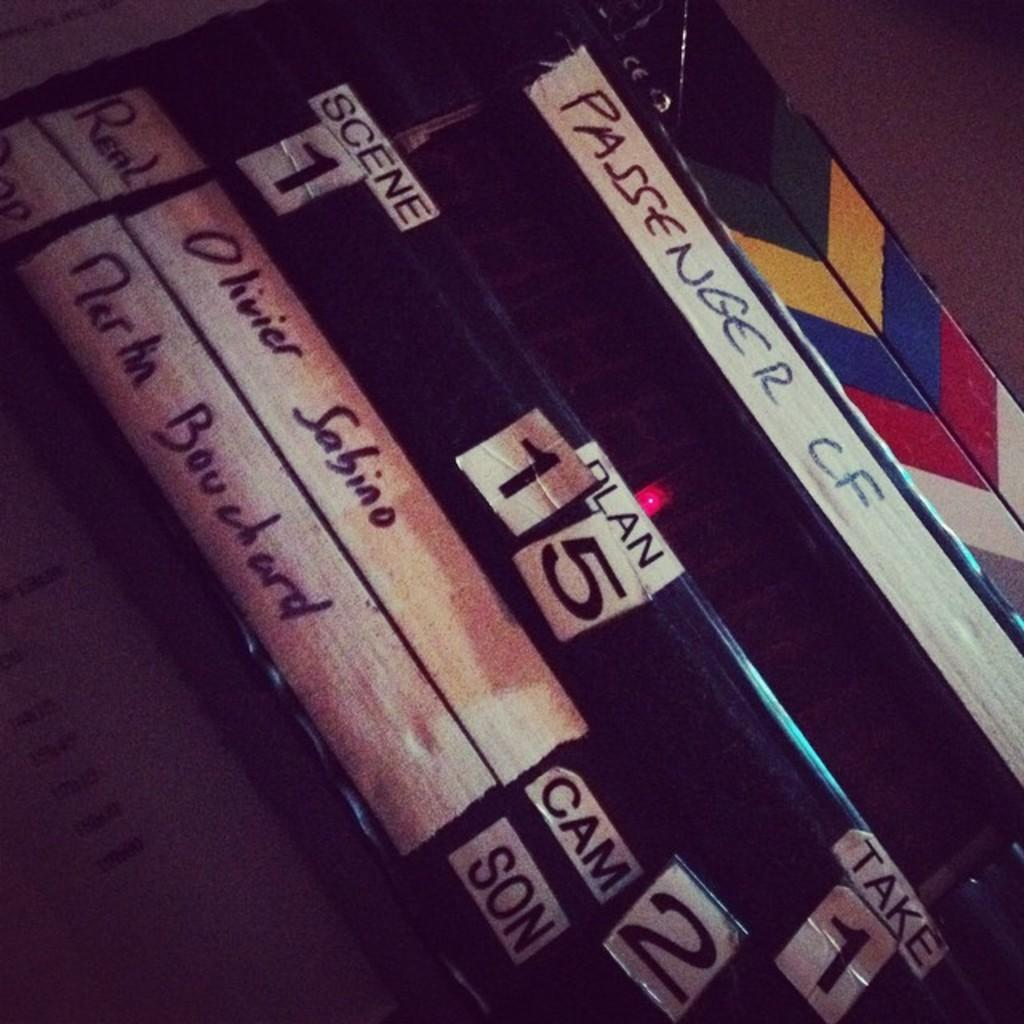Provide a one-sentence caption for the provided image. A scene board for the movie Passenger shows the scene and take numbers. 